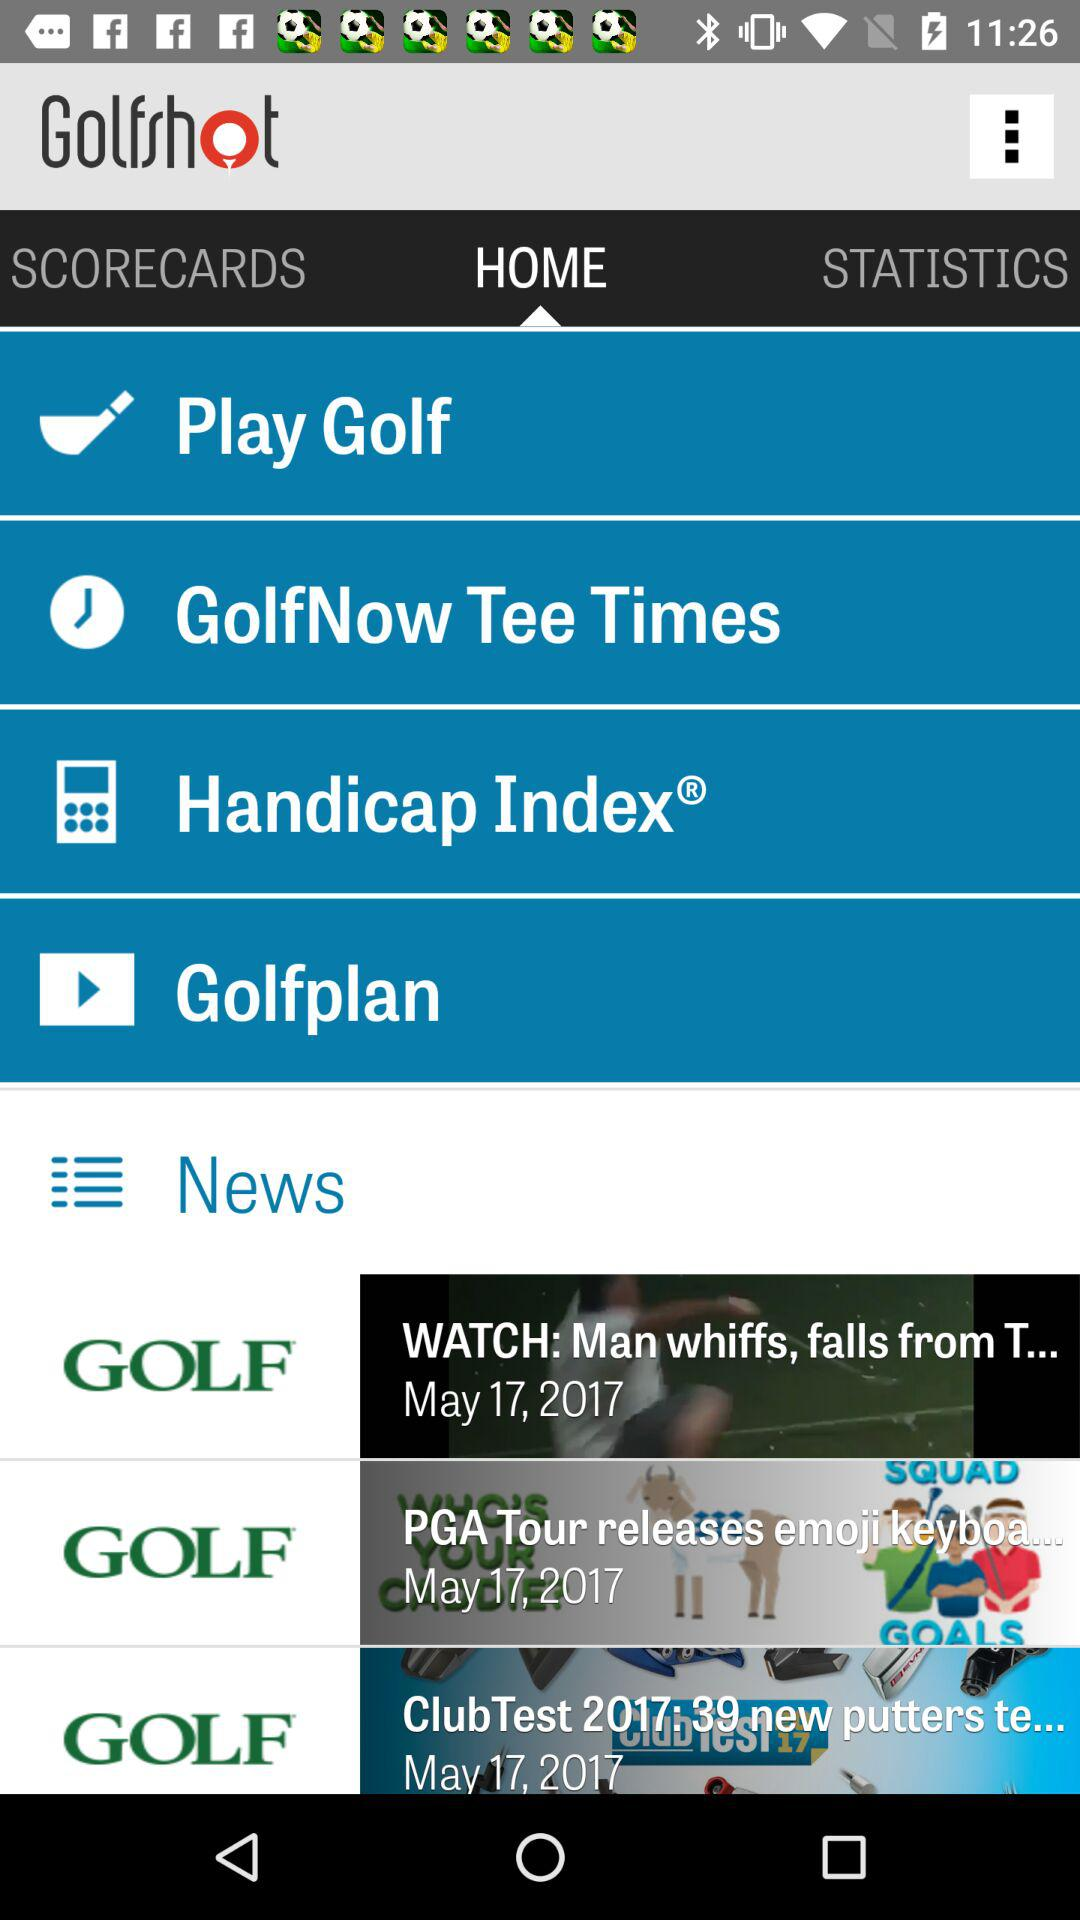What is the name of the application? The name of the application is "Golfshot". 